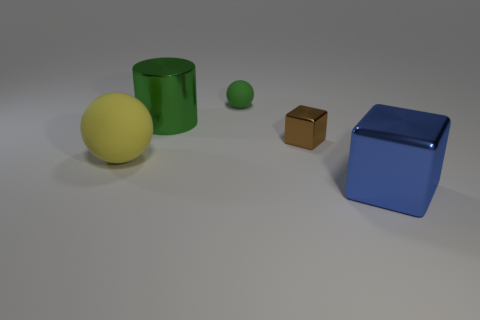Add 3 small green spheres. How many objects exist? 8 Subtract all cylinders. How many objects are left? 4 Subtract all green balls. Subtract all brown objects. How many objects are left? 3 Add 3 large blocks. How many large blocks are left? 4 Add 4 brown things. How many brown things exist? 5 Subtract 0 green blocks. How many objects are left? 5 